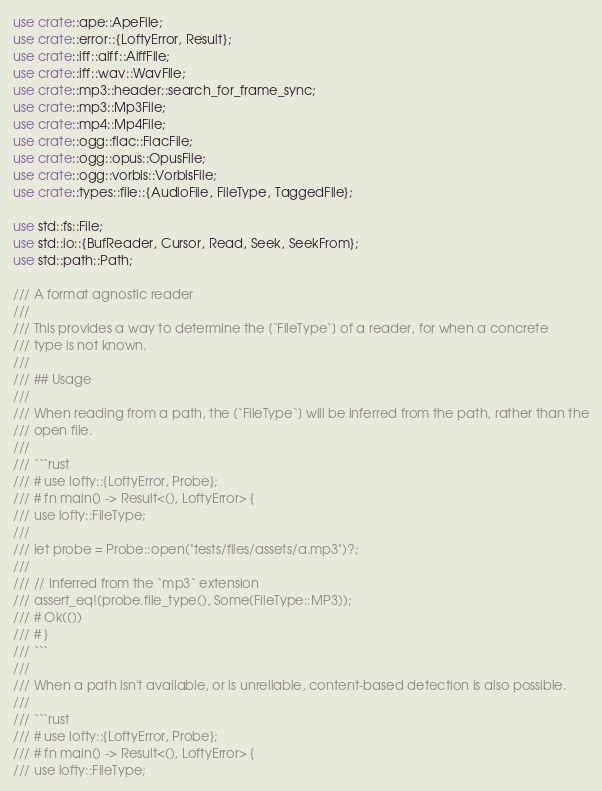Convert code to text. <code><loc_0><loc_0><loc_500><loc_500><_Rust_>use crate::ape::ApeFile;
use crate::error::{LoftyError, Result};
use crate::iff::aiff::AiffFile;
use crate::iff::wav::WavFile;
use crate::mp3::header::search_for_frame_sync;
use crate::mp3::Mp3File;
use crate::mp4::Mp4File;
use crate::ogg::flac::FlacFile;
use crate::ogg::opus::OpusFile;
use crate::ogg::vorbis::VorbisFile;
use crate::types::file::{AudioFile, FileType, TaggedFile};

use std::fs::File;
use std::io::{BufReader, Cursor, Read, Seek, SeekFrom};
use std::path::Path;

/// A format agnostic reader
///
/// This provides a way to determine the [`FileType`] of a reader, for when a concrete
/// type is not known.
///
/// ## Usage
///
/// When reading from a path, the [`FileType`] will be inferred from the path, rather than the
/// open file.
///
/// ```rust
/// # use lofty::{LoftyError, Probe};
/// # fn main() -> Result<(), LoftyError> {
/// use lofty::FileType;
///
/// let probe = Probe::open("tests/files/assets/a.mp3")?;
///
/// // Inferred from the `mp3` extension
/// assert_eq!(probe.file_type(), Some(FileType::MP3));
/// # Ok(())
/// # }
/// ```
///
/// When a path isn't available, or is unreliable, content-based detection is also possible.
///
/// ```rust
/// # use lofty::{LoftyError, Probe};
/// # fn main() -> Result<(), LoftyError> {
/// use lofty::FileType;</code> 